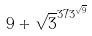Convert formula to latex. <formula><loc_0><loc_0><loc_500><loc_500>9 + \sqrt { 3 } ^ { 3 7 3 ^ { \sqrt { 9 } } }</formula> 